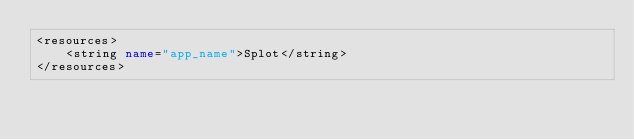Convert code to text. <code><loc_0><loc_0><loc_500><loc_500><_XML_><resources>
    <string name="app_name">Splot</string>
</resources>
</code> 